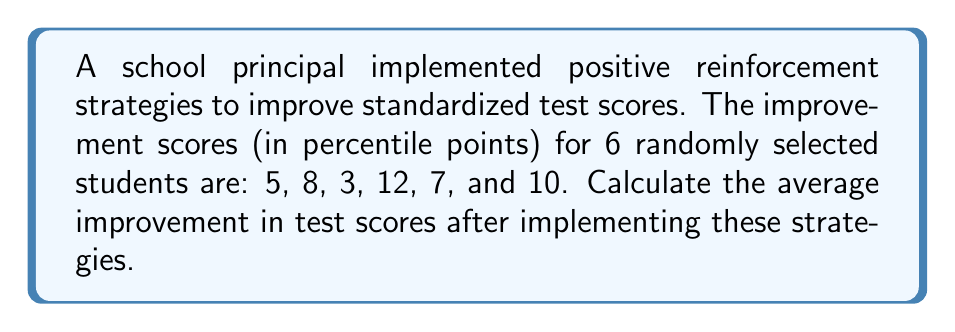Could you help me with this problem? To calculate the average improvement, we need to follow these steps:

1. Sum up all the improvement scores:
   $5 + 8 + 3 + 12 + 7 + 10 = 45$

2. Count the total number of students:
   There are 6 students in the sample.

3. Calculate the average by dividing the sum by the number of students:
   $$\text{Average} = \frac{\text{Sum of scores}}{\text{Number of students}} = \frac{45}{6} = 7.5$$

Therefore, the average improvement in standardized test scores after implementing positive reinforcement strategies is 7.5 percentile points.
Answer: 7.5 percentile points 